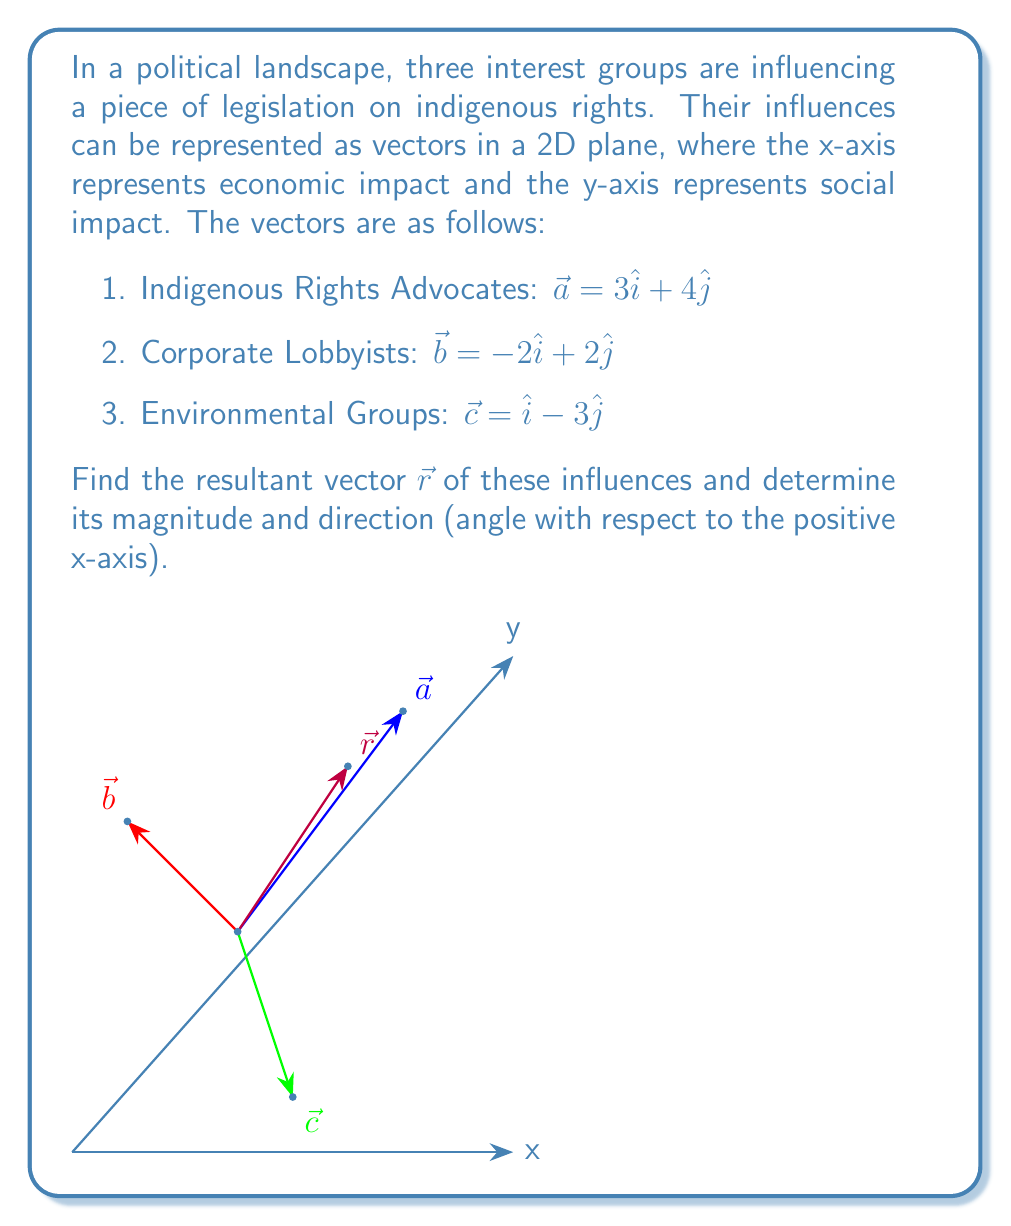Show me your answer to this math problem. To find the resultant vector, we need to add the three vectors:

$\vec{r} = \vec{a} + \vec{b} + \vec{c}$

Step 1: Add the x-components and y-components separately:
$\vec{r} = (3 - 2 + 1)\hat{i} + (4 + 2 - 3)\hat{j}$

Step 2: Simplify:
$\vec{r} = 2\hat{i} + 3\hat{j}$

Step 3: Calculate the magnitude of the resultant vector using the Pythagorean theorem:
$|\vec{r}| = \sqrt{2^2 + 3^2} = \sqrt{4 + 9} = \sqrt{13}$

Step 4: Calculate the direction (angle θ with respect to the positive x-axis) using the arctangent function:
$\theta = \tan^{-1}(\frac{y}{x}) = \tan^{-1}(\frac{3}{2})$

Step 5: Convert the angle to degrees:
$\theta = \tan^{-1}(\frac{3}{2}) \approx 56.31°$
Answer: $\vec{r} = 2\hat{i} + 3\hat{j}$, $|\vec{r}| = \sqrt{13}$, $\theta \approx 56.31°$ 